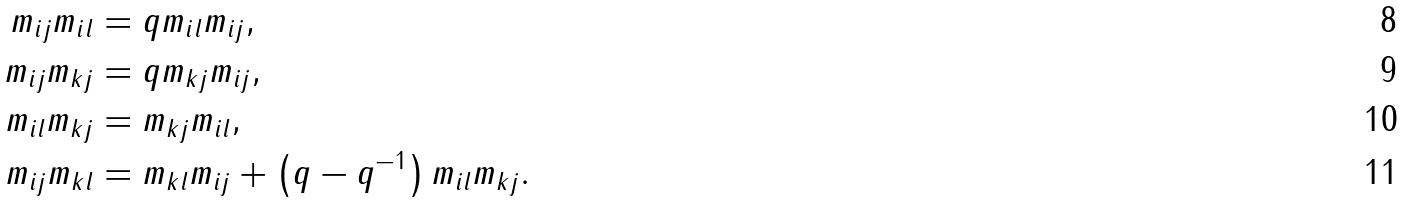<formula> <loc_0><loc_0><loc_500><loc_500>m _ { i j } m _ { i l } & = q m _ { i l } m _ { i j } , \\ m _ { i j } m _ { k j } & = q m _ { k j } m _ { i j } , \\ m _ { i l } m _ { k j } & = m _ { k j } m _ { i l } , \\ m _ { i j } m _ { k l } & = m _ { k l } m _ { i j } + \left ( q - q ^ { - 1 } \right ) m _ { i l } m _ { k j } .</formula> 